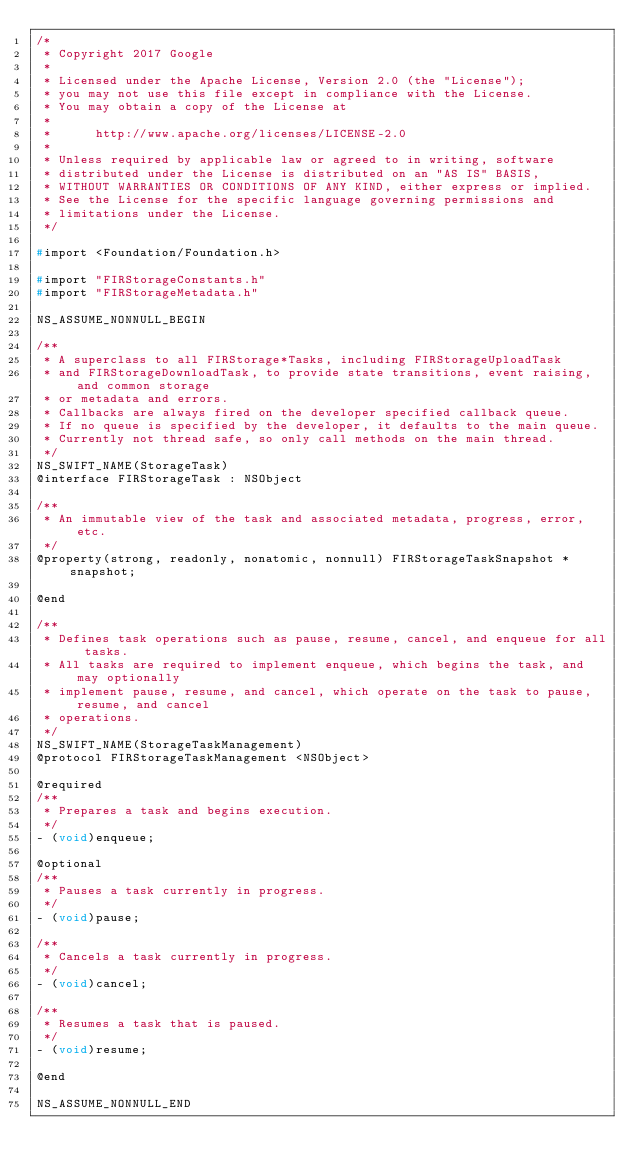<code> <loc_0><loc_0><loc_500><loc_500><_C_>/*
 * Copyright 2017 Google
 *
 * Licensed under the Apache License, Version 2.0 (the "License");
 * you may not use this file except in compliance with the License.
 * You may obtain a copy of the License at
 *
 *      http://www.apache.org/licenses/LICENSE-2.0
 *
 * Unless required by applicable law or agreed to in writing, software
 * distributed under the License is distributed on an "AS IS" BASIS,
 * WITHOUT WARRANTIES OR CONDITIONS OF ANY KIND, either express or implied.
 * See the License for the specific language governing permissions and
 * limitations under the License.
 */

#import <Foundation/Foundation.h>

#import "FIRStorageConstants.h"
#import "FIRStorageMetadata.h"

NS_ASSUME_NONNULL_BEGIN

/**
 * A superclass to all FIRStorage*Tasks, including FIRStorageUploadTask
 * and FIRStorageDownloadTask, to provide state transitions, event raising, and common storage
 * or metadata and errors.
 * Callbacks are always fired on the developer specified callback queue.
 * If no queue is specified by the developer, it defaults to the main queue.
 * Currently not thread safe, so only call methods on the main thread.
 */
NS_SWIFT_NAME(StorageTask)
@interface FIRStorageTask : NSObject

/**
 * An immutable view of the task and associated metadata, progress, error, etc.
 */
@property(strong, readonly, nonatomic, nonnull) FIRStorageTaskSnapshot *snapshot;

@end

/**
 * Defines task operations such as pause, resume, cancel, and enqueue for all tasks.
 * All tasks are required to implement enqueue, which begins the task, and may optionally
 * implement pause, resume, and cancel, which operate on the task to pause, resume, and cancel
 * operations.
 */
NS_SWIFT_NAME(StorageTaskManagement)
@protocol FIRStorageTaskManagement <NSObject>

@required
/**
 * Prepares a task and begins execution.
 */
- (void)enqueue;

@optional
/**
 * Pauses a task currently in progress.
 */
- (void)pause;

/**
 * Cancels a task currently in progress.
 */
- (void)cancel;

/**
 * Resumes a task that is paused.
 */
- (void)resume;

@end

NS_ASSUME_NONNULL_END
</code> 